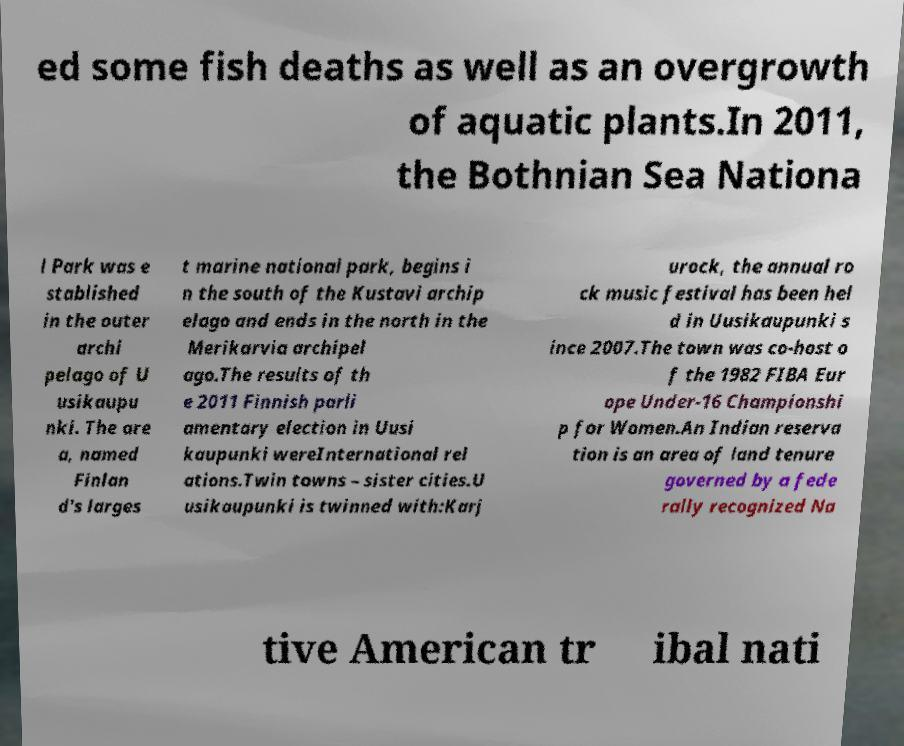I need the written content from this picture converted into text. Can you do that? ed some fish deaths as well as an overgrowth of aquatic plants.In 2011, the Bothnian Sea Nationa l Park was e stablished in the outer archi pelago of U usikaupu nki. The are a, named Finlan d's larges t marine national park, begins i n the south of the Kustavi archip elago and ends in the north in the Merikarvia archipel ago.The results of th e 2011 Finnish parli amentary election in Uusi kaupunki wereInternational rel ations.Twin towns – sister cities.U usikaupunki is twinned with:Karj urock, the annual ro ck music festival has been hel d in Uusikaupunki s ince 2007.The town was co-host o f the 1982 FIBA Eur ope Under-16 Championshi p for Women.An Indian reserva tion is an area of land tenure governed by a fede rally recognized Na tive American tr ibal nati 